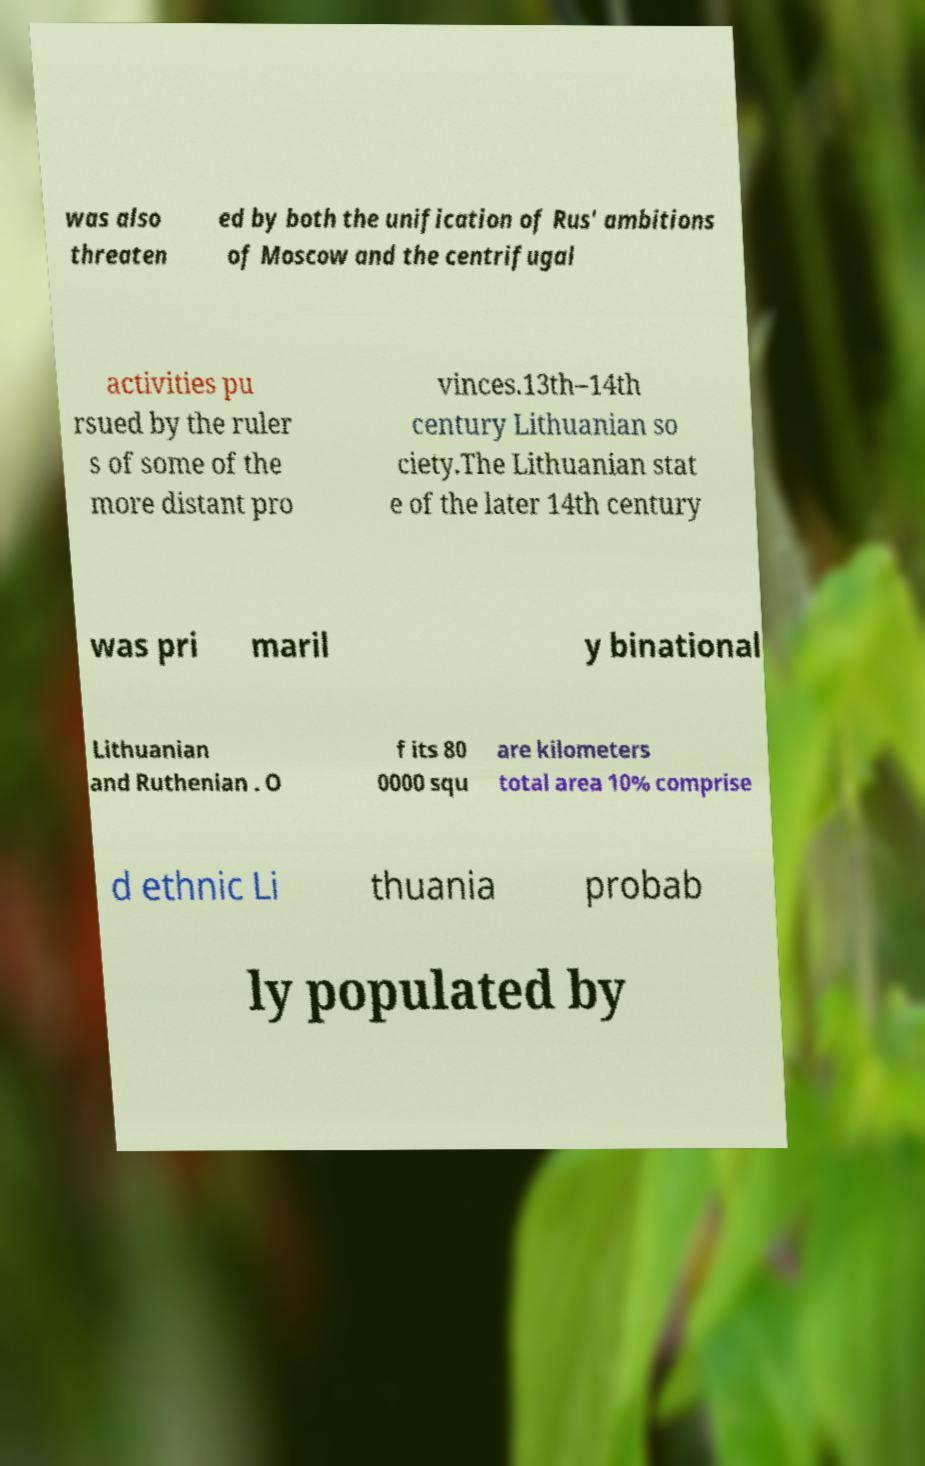What messages or text are displayed in this image? I need them in a readable, typed format. was also threaten ed by both the unification of Rus' ambitions of Moscow and the centrifugal activities pu rsued by the ruler s of some of the more distant pro vinces.13th–14th century Lithuanian so ciety.The Lithuanian stat e of the later 14th century was pri maril y binational Lithuanian and Ruthenian . O f its 80 0000 squ are kilometers total area 10% comprise d ethnic Li thuania probab ly populated by 